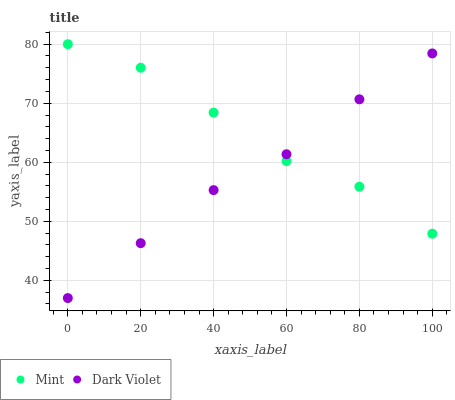Does Dark Violet have the minimum area under the curve?
Answer yes or no. Yes. Does Mint have the maximum area under the curve?
Answer yes or no. Yes. Does Dark Violet have the maximum area under the curve?
Answer yes or no. No. Is Dark Violet the smoothest?
Answer yes or no. Yes. Is Mint the roughest?
Answer yes or no. Yes. Is Dark Violet the roughest?
Answer yes or no. No. Does Dark Violet have the lowest value?
Answer yes or no. Yes. Does Mint have the highest value?
Answer yes or no. Yes. Does Dark Violet have the highest value?
Answer yes or no. No. Does Dark Violet intersect Mint?
Answer yes or no. Yes. Is Dark Violet less than Mint?
Answer yes or no. No. Is Dark Violet greater than Mint?
Answer yes or no. No. 